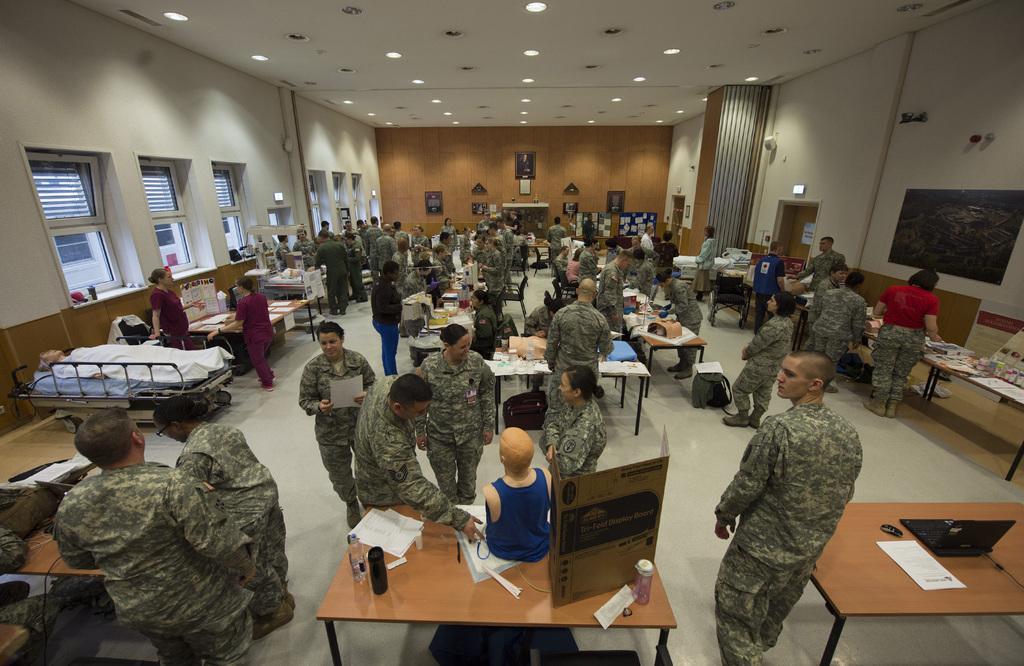How would you summarize this image in a sentence or two? This is an inside view of a hall. In this image I can see many tables on the ground. On the left side there are two persons lying on the beds and I can see windows to the wall. On the tables there are many objects like laptops, card boxes, bottles, papers and many others. Here I can see many people are wearing uniforms and standing on the floor. On the right side there is a screen attached to the wall. At the top of the image I can see few lights. In the background there are few photo frames attached to the wall. 